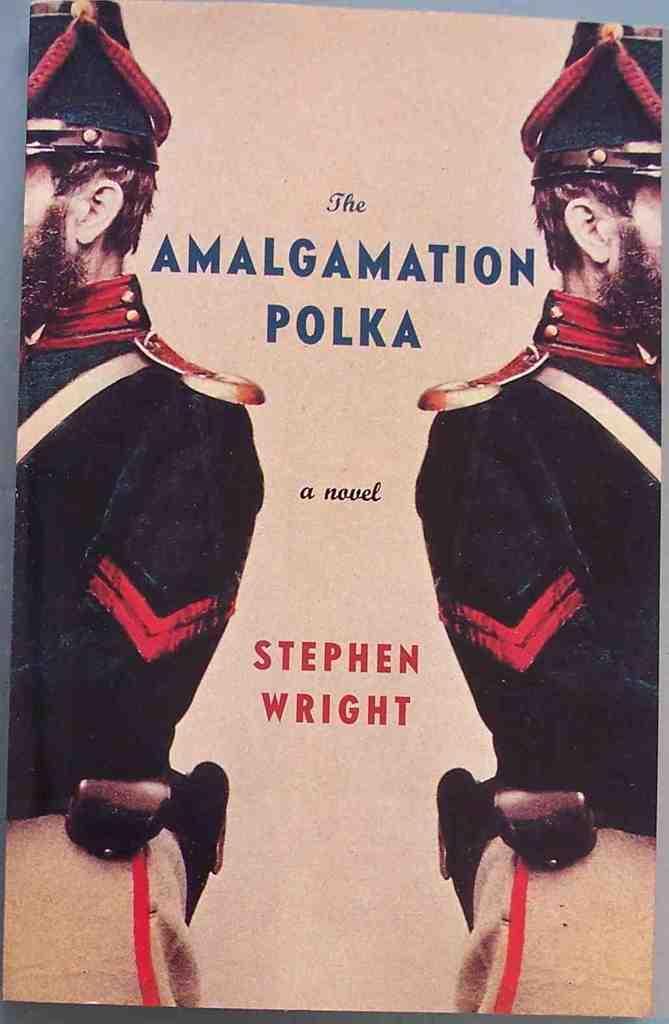Could you give a brief overview of what you see in this image? In this picture we can see a poster, here we can see two people and some text. 